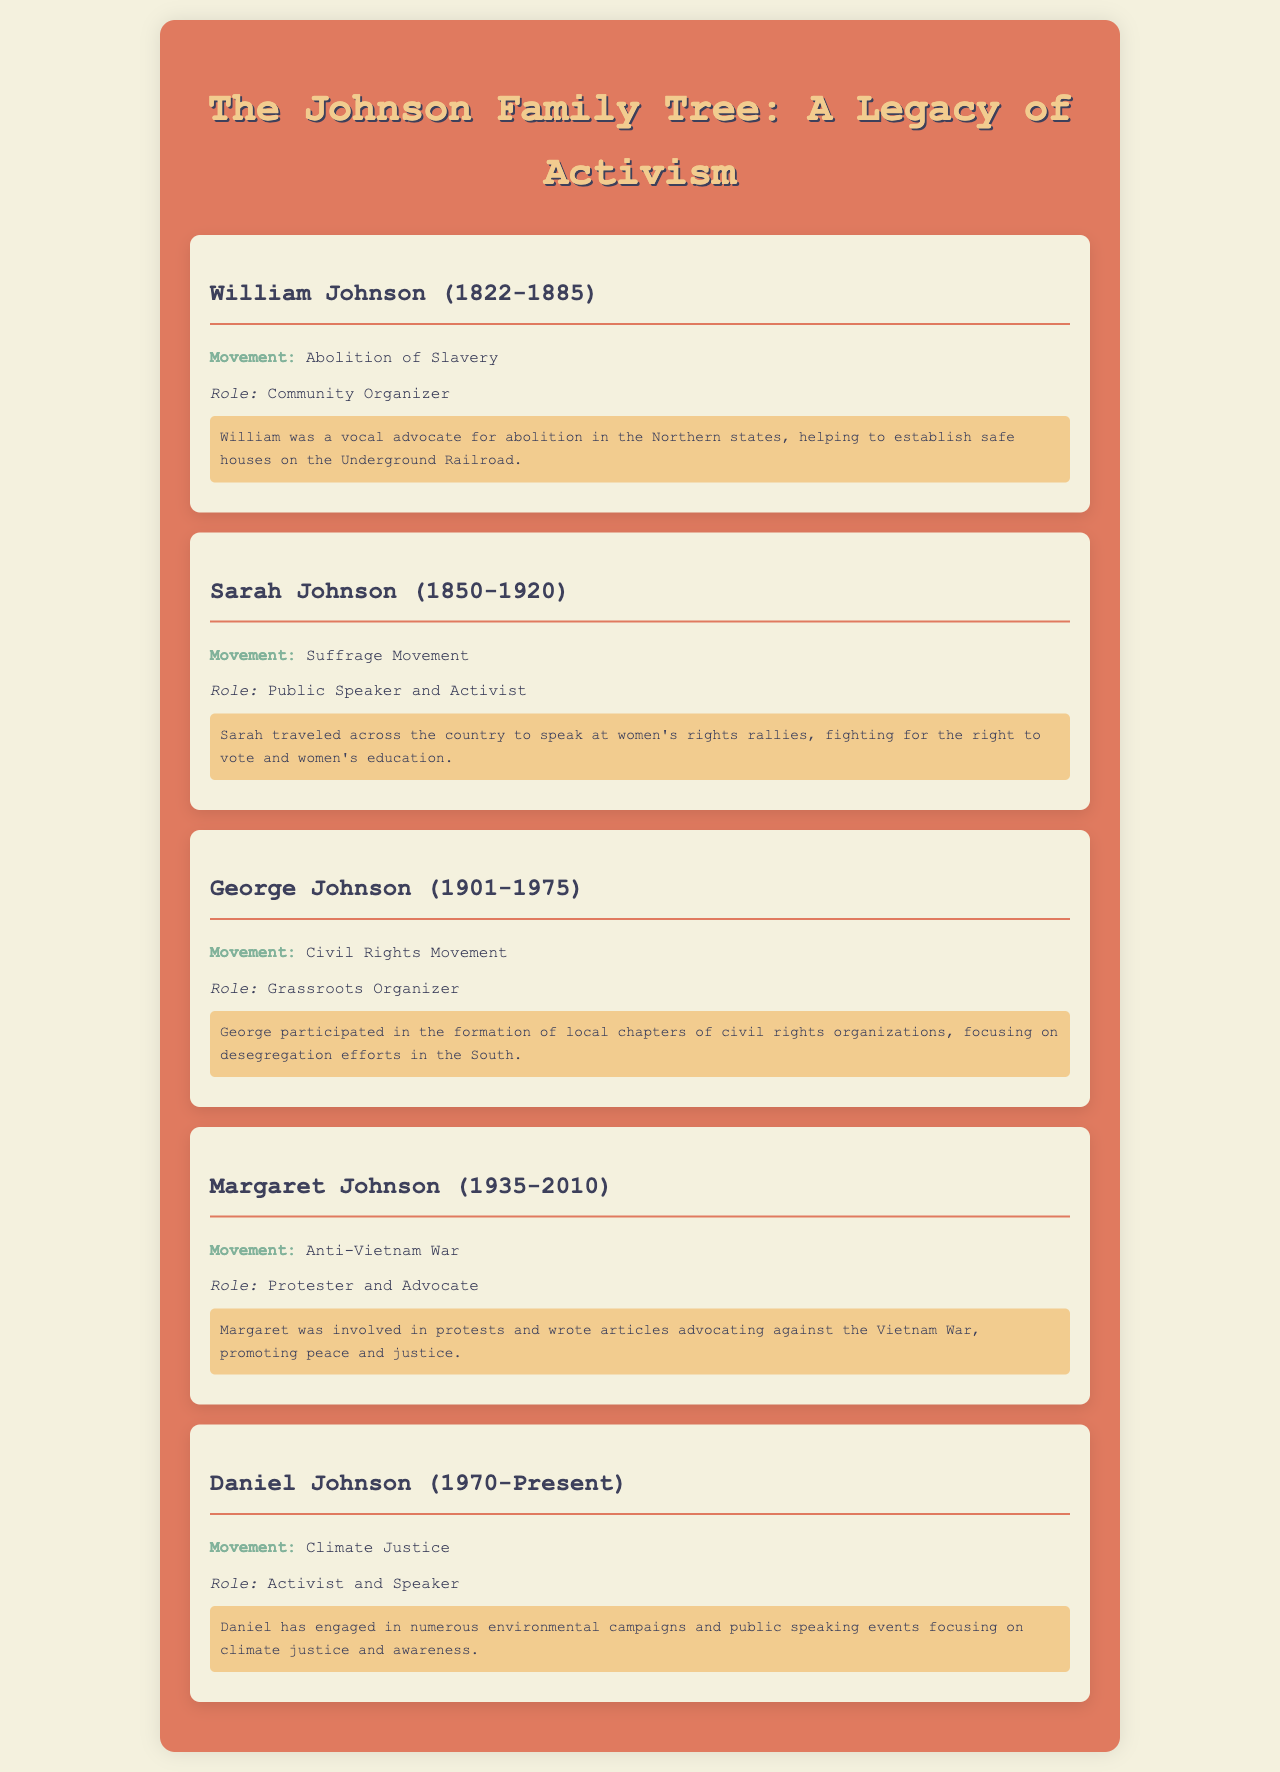What was William Johnson's role? William Johnson's role was stated as a community organizer in the document.
Answer: Community Organizer What movement was associated with Sarah Johnson? The document specifies that Sarah Johnson was associated with the Suffrage Movement.
Answer: Suffrage Movement In what year was George Johnson born? The birth year of George Johnson can be found in the document, which is 1901.
Answer: 1901 Who was involved in the Anti-Vietnam War movement? The document mentions Margaret Johnson as being involved in the Anti-Vietnam War movement.
Answer: Margaret Johnson What is Daniel Johnson's current contribution? The document describes Daniel Johnson's current role as an activist and speaker focusing on climate justice.
Answer: Activist and Speaker What kind of articles did Margaret Johnson write? The document states that Margaret Johnson wrote articles advocating against the Vietnam War.
Answer: Advocacy Articles Which family member was a public speaker? The document indicates that Sarah Johnson served as a public speaker and activist.
Answer: Sarah Johnson How many members are listed in the Johnson family tree? The document lists a total of five family members in the Johnson family tree.
Answer: Five 